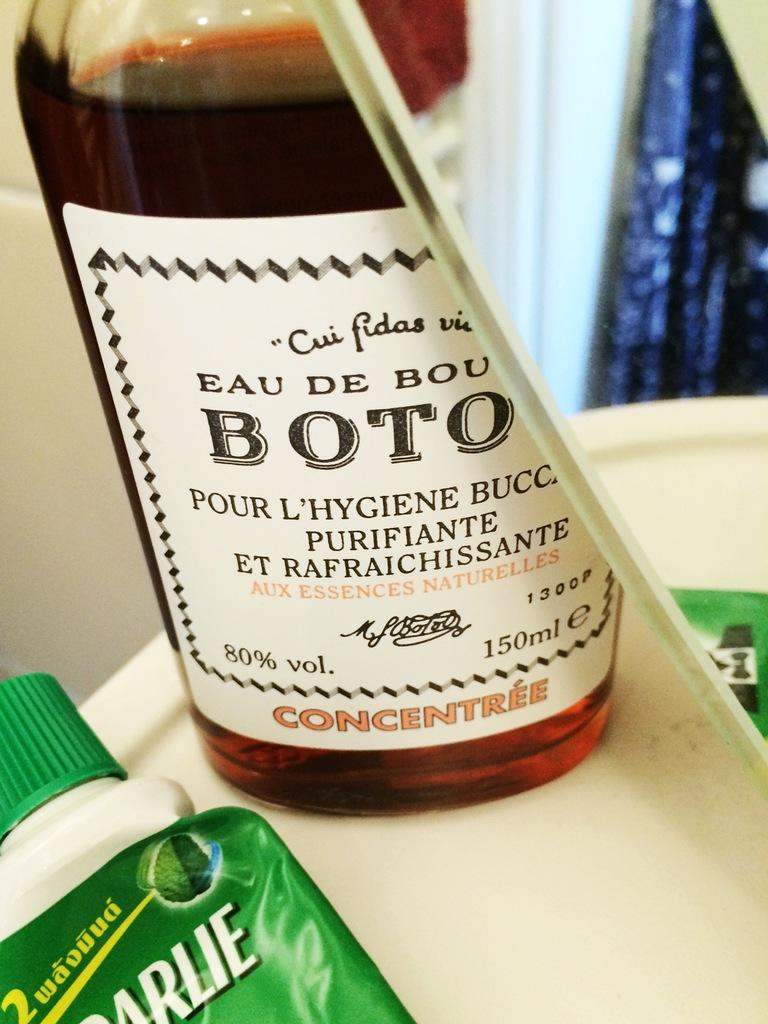Provide a one-sentence caption for the provided image. A bottle with brown liquid in it that is a concentree. 